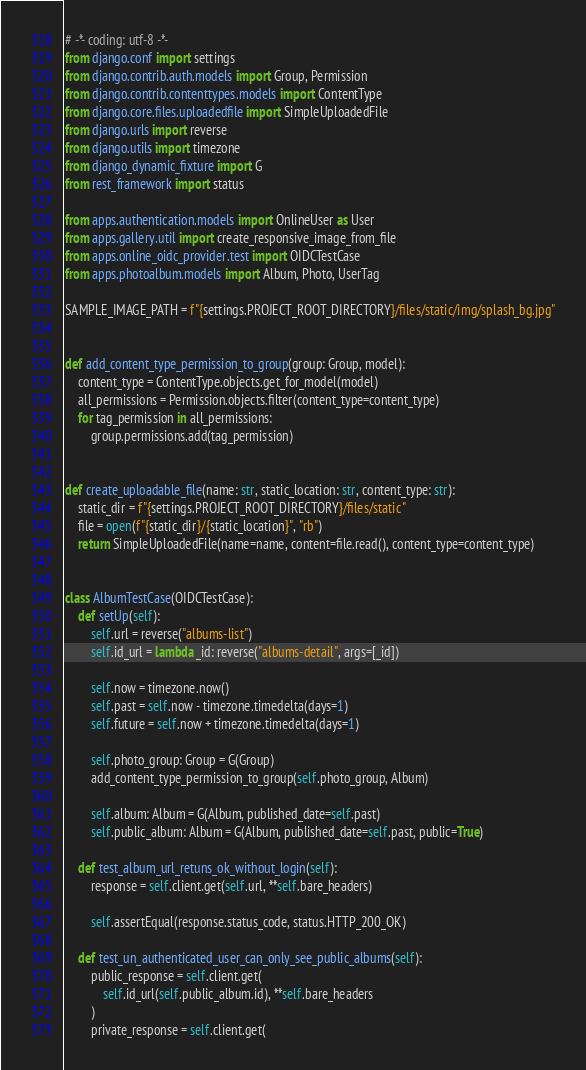<code> <loc_0><loc_0><loc_500><loc_500><_Python_># -*- coding: utf-8 -*-
from django.conf import settings
from django.contrib.auth.models import Group, Permission
from django.contrib.contenttypes.models import ContentType
from django.core.files.uploadedfile import SimpleUploadedFile
from django.urls import reverse
from django.utils import timezone
from django_dynamic_fixture import G
from rest_framework import status

from apps.authentication.models import OnlineUser as User
from apps.gallery.util import create_responsive_image_from_file
from apps.online_oidc_provider.test import OIDCTestCase
from apps.photoalbum.models import Album, Photo, UserTag

SAMPLE_IMAGE_PATH = f"{settings.PROJECT_ROOT_DIRECTORY}/files/static/img/splash_bg.jpg"


def add_content_type_permission_to_group(group: Group, model):
    content_type = ContentType.objects.get_for_model(model)
    all_permissions = Permission.objects.filter(content_type=content_type)
    for tag_permission in all_permissions:
        group.permissions.add(tag_permission)


def create_uploadable_file(name: str, static_location: str, content_type: str):
    static_dir = f"{settings.PROJECT_ROOT_DIRECTORY}/files/static"
    file = open(f"{static_dir}/{static_location}", "rb")
    return SimpleUploadedFile(name=name, content=file.read(), content_type=content_type)


class AlbumTestCase(OIDCTestCase):
    def setUp(self):
        self.url = reverse("albums-list")
        self.id_url = lambda _id: reverse("albums-detail", args=[_id])

        self.now = timezone.now()
        self.past = self.now - timezone.timedelta(days=1)
        self.future = self.now + timezone.timedelta(days=1)

        self.photo_group: Group = G(Group)
        add_content_type_permission_to_group(self.photo_group, Album)

        self.album: Album = G(Album, published_date=self.past)
        self.public_album: Album = G(Album, published_date=self.past, public=True)

    def test_album_url_retuns_ok_without_login(self):
        response = self.client.get(self.url, **self.bare_headers)

        self.assertEqual(response.status_code, status.HTTP_200_OK)

    def test_un_authenticated_user_can_only_see_public_albums(self):
        public_response = self.client.get(
            self.id_url(self.public_album.id), **self.bare_headers
        )
        private_response = self.client.get(</code> 